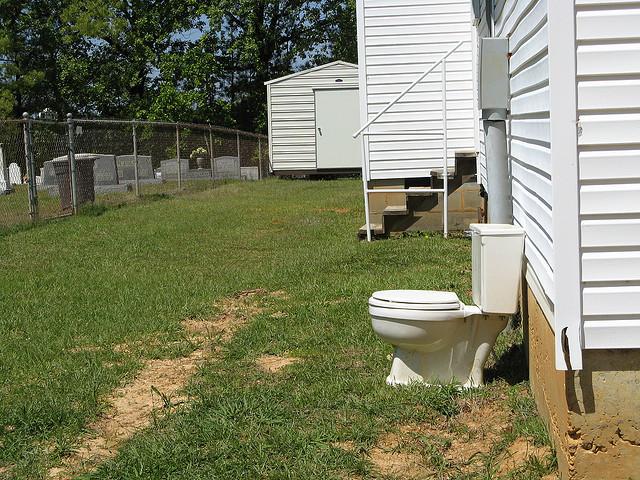Is this innovative?
Answer briefly. No. How many steps are there?
Short answer required. 5. What color is the toilet?
Quick response, please. White. Is the toilet functional?
Concise answer only. No. Is there a path?
Concise answer only. Yes. 